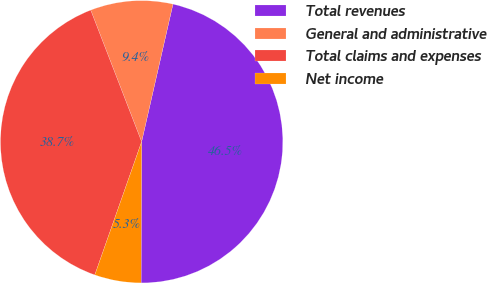Convert chart. <chart><loc_0><loc_0><loc_500><loc_500><pie_chart><fcel>Total revenues<fcel>General and administrative<fcel>Total claims and expenses<fcel>Net income<nl><fcel>46.5%<fcel>9.44%<fcel>38.75%<fcel>5.32%<nl></chart> 